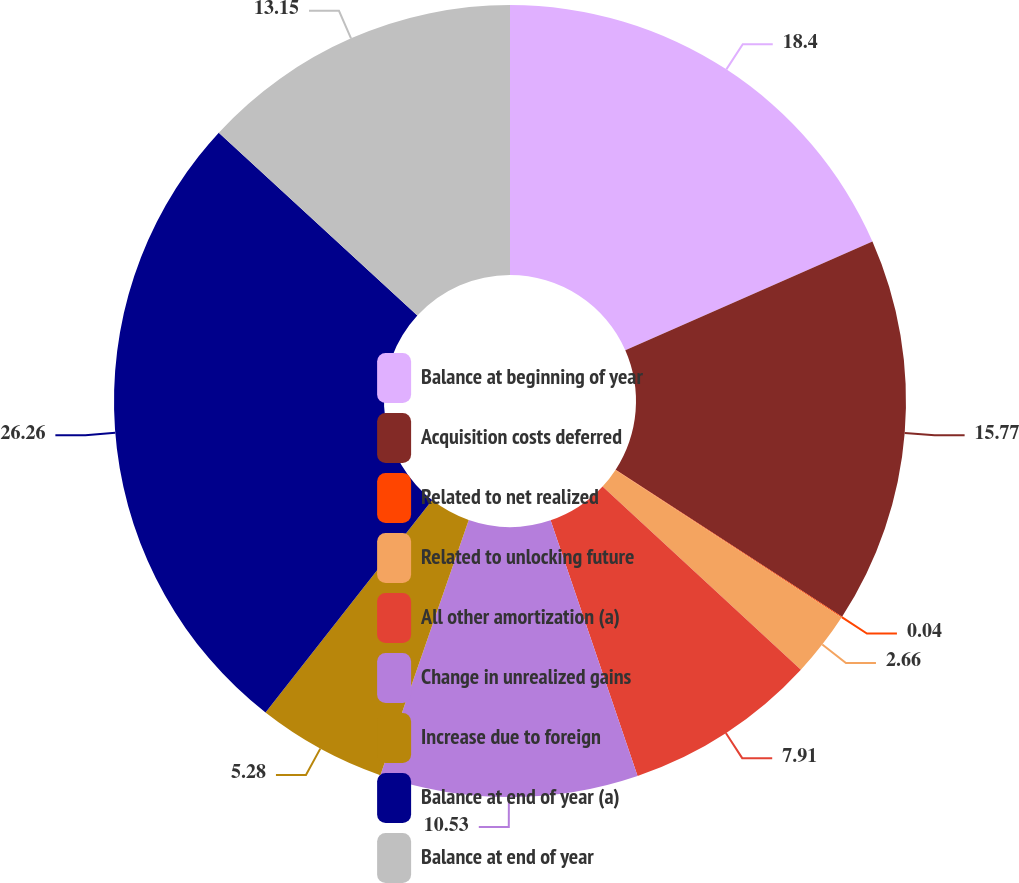Convert chart to OTSL. <chart><loc_0><loc_0><loc_500><loc_500><pie_chart><fcel>Balance at beginning of year<fcel>Acquisition costs deferred<fcel>Related to net realized<fcel>Related to unlocking future<fcel>All other amortization (a)<fcel>Change in unrealized gains<fcel>Increase due to foreign<fcel>Balance at end of year (a)<fcel>Balance at end of year<nl><fcel>18.4%<fcel>15.77%<fcel>0.04%<fcel>2.66%<fcel>7.91%<fcel>10.53%<fcel>5.28%<fcel>26.26%<fcel>13.15%<nl></chart> 